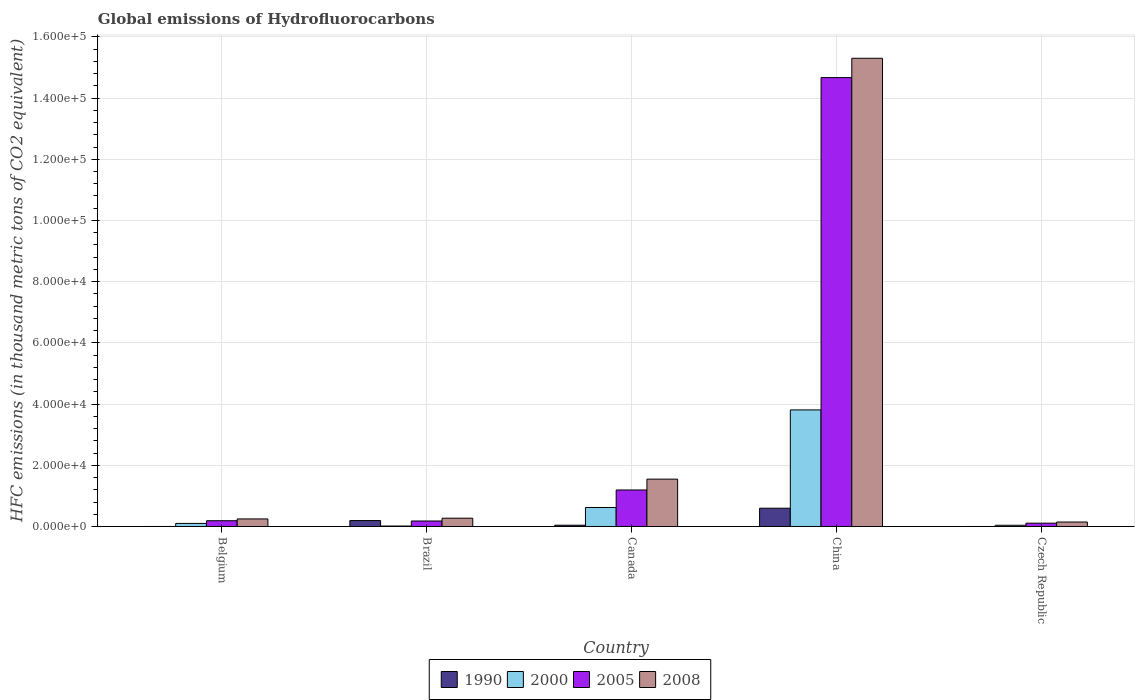How many different coloured bars are there?
Provide a succinct answer. 4. Are the number of bars on each tick of the X-axis equal?
Offer a very short reply. Yes. How many bars are there on the 3rd tick from the right?
Provide a short and direct response. 4. What is the label of the 1st group of bars from the left?
Ensure brevity in your answer.  Belgium. In how many cases, is the number of bars for a given country not equal to the number of legend labels?
Offer a terse response. 0. What is the global emissions of Hydrofluorocarbons in 2000 in Canada?
Your answer should be compact. 6202.8. Across all countries, what is the maximum global emissions of Hydrofluorocarbons in 2008?
Provide a short and direct response. 1.53e+05. Across all countries, what is the minimum global emissions of Hydrofluorocarbons in 2008?
Ensure brevity in your answer.  1459. In which country was the global emissions of Hydrofluorocarbons in 1990 minimum?
Keep it short and to the point. Czech Republic. What is the total global emissions of Hydrofluorocarbons in 2008 in the graph?
Your response must be concise. 1.75e+05. What is the difference between the global emissions of Hydrofluorocarbons in 2005 in Canada and that in China?
Your answer should be compact. -1.35e+05. What is the difference between the global emissions of Hydrofluorocarbons in 2000 in China and the global emissions of Hydrofluorocarbons in 2008 in Canada?
Offer a terse response. 2.26e+04. What is the average global emissions of Hydrofluorocarbons in 2005 per country?
Offer a terse response. 3.27e+04. What is the difference between the global emissions of Hydrofluorocarbons of/in 2008 and global emissions of Hydrofluorocarbons of/in 2005 in China?
Offer a very short reply. 6309. In how many countries, is the global emissions of Hydrofluorocarbons in 2005 greater than 156000 thousand metric tons?
Your answer should be very brief. 0. What is the ratio of the global emissions of Hydrofluorocarbons in 2008 in Belgium to that in China?
Ensure brevity in your answer.  0.02. Is the global emissions of Hydrofluorocarbons in 2008 in Belgium less than that in Canada?
Provide a succinct answer. Yes. Is the difference between the global emissions of Hydrofluorocarbons in 2008 in Brazil and China greater than the difference between the global emissions of Hydrofluorocarbons in 2005 in Brazil and China?
Provide a short and direct response. No. What is the difference between the highest and the second highest global emissions of Hydrofluorocarbons in 2005?
Your answer should be very brief. -1.35e+05. What is the difference between the highest and the lowest global emissions of Hydrofluorocarbons in 2005?
Provide a succinct answer. 1.46e+05. Is it the case that in every country, the sum of the global emissions of Hydrofluorocarbons in 1990 and global emissions of Hydrofluorocarbons in 2008 is greater than the global emissions of Hydrofluorocarbons in 2000?
Ensure brevity in your answer.  Yes. Are all the bars in the graph horizontal?
Provide a succinct answer. No. Are the values on the major ticks of Y-axis written in scientific E-notation?
Provide a short and direct response. Yes. Does the graph contain grids?
Your answer should be compact. Yes. Where does the legend appear in the graph?
Offer a terse response. Bottom center. How are the legend labels stacked?
Ensure brevity in your answer.  Horizontal. What is the title of the graph?
Your response must be concise. Global emissions of Hydrofluorocarbons. Does "2003" appear as one of the legend labels in the graph?
Provide a short and direct response. No. What is the label or title of the X-axis?
Give a very brief answer. Country. What is the label or title of the Y-axis?
Your answer should be very brief. HFC emissions (in thousand metric tons of CO2 equivalent). What is the HFC emissions (in thousand metric tons of CO2 equivalent) in 2000 in Belgium?
Give a very brief answer. 997.7. What is the HFC emissions (in thousand metric tons of CO2 equivalent) in 2005 in Belgium?
Make the answer very short. 1882.6. What is the HFC emissions (in thousand metric tons of CO2 equivalent) in 2008 in Belgium?
Offer a very short reply. 2471.1. What is the HFC emissions (in thousand metric tons of CO2 equivalent) of 1990 in Brazil?
Provide a succinct answer. 1930.7. What is the HFC emissions (in thousand metric tons of CO2 equivalent) of 2000 in Brazil?
Provide a short and direct response. 147.4. What is the HFC emissions (in thousand metric tons of CO2 equivalent) of 2005 in Brazil?
Keep it short and to the point. 1793.4. What is the HFC emissions (in thousand metric tons of CO2 equivalent) in 2008 in Brazil?
Provide a short and direct response. 2707.5. What is the HFC emissions (in thousand metric tons of CO2 equivalent) of 1990 in Canada?
Offer a terse response. 418.5. What is the HFC emissions (in thousand metric tons of CO2 equivalent) of 2000 in Canada?
Your answer should be compact. 6202.8. What is the HFC emissions (in thousand metric tons of CO2 equivalent) of 2005 in Canada?
Your answer should be very brief. 1.19e+04. What is the HFC emissions (in thousand metric tons of CO2 equivalent) of 2008 in Canada?
Keep it short and to the point. 1.55e+04. What is the HFC emissions (in thousand metric tons of CO2 equivalent) of 1990 in China?
Your response must be concise. 5970.1. What is the HFC emissions (in thousand metric tons of CO2 equivalent) of 2000 in China?
Offer a very short reply. 3.81e+04. What is the HFC emissions (in thousand metric tons of CO2 equivalent) in 2005 in China?
Provide a succinct answer. 1.47e+05. What is the HFC emissions (in thousand metric tons of CO2 equivalent) in 2008 in China?
Provide a short and direct response. 1.53e+05. What is the HFC emissions (in thousand metric tons of CO2 equivalent) of 1990 in Czech Republic?
Make the answer very short. 0.1. What is the HFC emissions (in thousand metric tons of CO2 equivalent) in 2000 in Czech Republic?
Your response must be concise. 399.5. What is the HFC emissions (in thousand metric tons of CO2 equivalent) of 2005 in Czech Republic?
Provide a short and direct response. 1078.7. What is the HFC emissions (in thousand metric tons of CO2 equivalent) in 2008 in Czech Republic?
Make the answer very short. 1459. Across all countries, what is the maximum HFC emissions (in thousand metric tons of CO2 equivalent) in 1990?
Make the answer very short. 5970.1. Across all countries, what is the maximum HFC emissions (in thousand metric tons of CO2 equivalent) of 2000?
Your response must be concise. 3.81e+04. Across all countries, what is the maximum HFC emissions (in thousand metric tons of CO2 equivalent) of 2005?
Your answer should be very brief. 1.47e+05. Across all countries, what is the maximum HFC emissions (in thousand metric tons of CO2 equivalent) of 2008?
Give a very brief answer. 1.53e+05. Across all countries, what is the minimum HFC emissions (in thousand metric tons of CO2 equivalent) in 1990?
Offer a very short reply. 0.1. Across all countries, what is the minimum HFC emissions (in thousand metric tons of CO2 equivalent) in 2000?
Your answer should be very brief. 147.4. Across all countries, what is the minimum HFC emissions (in thousand metric tons of CO2 equivalent) of 2005?
Make the answer very short. 1078.7. Across all countries, what is the minimum HFC emissions (in thousand metric tons of CO2 equivalent) in 2008?
Offer a very short reply. 1459. What is the total HFC emissions (in thousand metric tons of CO2 equivalent) of 1990 in the graph?
Offer a very short reply. 8319.9. What is the total HFC emissions (in thousand metric tons of CO2 equivalent) in 2000 in the graph?
Your answer should be compact. 4.58e+04. What is the total HFC emissions (in thousand metric tons of CO2 equivalent) in 2005 in the graph?
Provide a short and direct response. 1.63e+05. What is the total HFC emissions (in thousand metric tons of CO2 equivalent) in 2008 in the graph?
Your response must be concise. 1.75e+05. What is the difference between the HFC emissions (in thousand metric tons of CO2 equivalent) in 1990 in Belgium and that in Brazil?
Keep it short and to the point. -1930.2. What is the difference between the HFC emissions (in thousand metric tons of CO2 equivalent) of 2000 in Belgium and that in Brazil?
Provide a succinct answer. 850.3. What is the difference between the HFC emissions (in thousand metric tons of CO2 equivalent) of 2005 in Belgium and that in Brazil?
Give a very brief answer. 89.2. What is the difference between the HFC emissions (in thousand metric tons of CO2 equivalent) in 2008 in Belgium and that in Brazil?
Your response must be concise. -236.4. What is the difference between the HFC emissions (in thousand metric tons of CO2 equivalent) in 1990 in Belgium and that in Canada?
Your answer should be compact. -418. What is the difference between the HFC emissions (in thousand metric tons of CO2 equivalent) in 2000 in Belgium and that in Canada?
Your response must be concise. -5205.1. What is the difference between the HFC emissions (in thousand metric tons of CO2 equivalent) in 2005 in Belgium and that in Canada?
Keep it short and to the point. -1.00e+04. What is the difference between the HFC emissions (in thousand metric tons of CO2 equivalent) of 2008 in Belgium and that in Canada?
Give a very brief answer. -1.30e+04. What is the difference between the HFC emissions (in thousand metric tons of CO2 equivalent) in 1990 in Belgium and that in China?
Provide a succinct answer. -5969.6. What is the difference between the HFC emissions (in thousand metric tons of CO2 equivalent) of 2000 in Belgium and that in China?
Keep it short and to the point. -3.71e+04. What is the difference between the HFC emissions (in thousand metric tons of CO2 equivalent) in 2005 in Belgium and that in China?
Your answer should be very brief. -1.45e+05. What is the difference between the HFC emissions (in thousand metric tons of CO2 equivalent) in 2008 in Belgium and that in China?
Your answer should be compact. -1.51e+05. What is the difference between the HFC emissions (in thousand metric tons of CO2 equivalent) in 1990 in Belgium and that in Czech Republic?
Give a very brief answer. 0.4. What is the difference between the HFC emissions (in thousand metric tons of CO2 equivalent) of 2000 in Belgium and that in Czech Republic?
Offer a terse response. 598.2. What is the difference between the HFC emissions (in thousand metric tons of CO2 equivalent) in 2005 in Belgium and that in Czech Republic?
Give a very brief answer. 803.9. What is the difference between the HFC emissions (in thousand metric tons of CO2 equivalent) of 2008 in Belgium and that in Czech Republic?
Your response must be concise. 1012.1. What is the difference between the HFC emissions (in thousand metric tons of CO2 equivalent) of 1990 in Brazil and that in Canada?
Ensure brevity in your answer.  1512.2. What is the difference between the HFC emissions (in thousand metric tons of CO2 equivalent) in 2000 in Brazil and that in Canada?
Offer a terse response. -6055.4. What is the difference between the HFC emissions (in thousand metric tons of CO2 equivalent) of 2005 in Brazil and that in Canada?
Provide a short and direct response. -1.01e+04. What is the difference between the HFC emissions (in thousand metric tons of CO2 equivalent) of 2008 in Brazil and that in Canada?
Your answer should be very brief. -1.28e+04. What is the difference between the HFC emissions (in thousand metric tons of CO2 equivalent) in 1990 in Brazil and that in China?
Your answer should be compact. -4039.4. What is the difference between the HFC emissions (in thousand metric tons of CO2 equivalent) in 2000 in Brazil and that in China?
Your answer should be very brief. -3.79e+04. What is the difference between the HFC emissions (in thousand metric tons of CO2 equivalent) in 2005 in Brazil and that in China?
Ensure brevity in your answer.  -1.45e+05. What is the difference between the HFC emissions (in thousand metric tons of CO2 equivalent) in 2008 in Brazil and that in China?
Make the answer very short. -1.50e+05. What is the difference between the HFC emissions (in thousand metric tons of CO2 equivalent) in 1990 in Brazil and that in Czech Republic?
Keep it short and to the point. 1930.6. What is the difference between the HFC emissions (in thousand metric tons of CO2 equivalent) in 2000 in Brazil and that in Czech Republic?
Give a very brief answer. -252.1. What is the difference between the HFC emissions (in thousand metric tons of CO2 equivalent) in 2005 in Brazil and that in Czech Republic?
Keep it short and to the point. 714.7. What is the difference between the HFC emissions (in thousand metric tons of CO2 equivalent) of 2008 in Brazil and that in Czech Republic?
Provide a short and direct response. 1248.5. What is the difference between the HFC emissions (in thousand metric tons of CO2 equivalent) of 1990 in Canada and that in China?
Provide a short and direct response. -5551.6. What is the difference between the HFC emissions (in thousand metric tons of CO2 equivalent) of 2000 in Canada and that in China?
Your response must be concise. -3.19e+04. What is the difference between the HFC emissions (in thousand metric tons of CO2 equivalent) in 2005 in Canada and that in China?
Keep it short and to the point. -1.35e+05. What is the difference between the HFC emissions (in thousand metric tons of CO2 equivalent) in 2008 in Canada and that in China?
Offer a terse response. -1.38e+05. What is the difference between the HFC emissions (in thousand metric tons of CO2 equivalent) of 1990 in Canada and that in Czech Republic?
Your answer should be very brief. 418.4. What is the difference between the HFC emissions (in thousand metric tons of CO2 equivalent) in 2000 in Canada and that in Czech Republic?
Give a very brief answer. 5803.3. What is the difference between the HFC emissions (in thousand metric tons of CO2 equivalent) in 2005 in Canada and that in Czech Republic?
Make the answer very short. 1.08e+04. What is the difference between the HFC emissions (in thousand metric tons of CO2 equivalent) of 2008 in Canada and that in Czech Republic?
Provide a short and direct response. 1.40e+04. What is the difference between the HFC emissions (in thousand metric tons of CO2 equivalent) in 1990 in China and that in Czech Republic?
Keep it short and to the point. 5970. What is the difference between the HFC emissions (in thousand metric tons of CO2 equivalent) of 2000 in China and that in Czech Republic?
Keep it short and to the point. 3.77e+04. What is the difference between the HFC emissions (in thousand metric tons of CO2 equivalent) of 2005 in China and that in Czech Republic?
Offer a very short reply. 1.46e+05. What is the difference between the HFC emissions (in thousand metric tons of CO2 equivalent) in 2008 in China and that in Czech Republic?
Your response must be concise. 1.52e+05. What is the difference between the HFC emissions (in thousand metric tons of CO2 equivalent) of 1990 in Belgium and the HFC emissions (in thousand metric tons of CO2 equivalent) of 2000 in Brazil?
Offer a very short reply. -146.9. What is the difference between the HFC emissions (in thousand metric tons of CO2 equivalent) in 1990 in Belgium and the HFC emissions (in thousand metric tons of CO2 equivalent) in 2005 in Brazil?
Make the answer very short. -1792.9. What is the difference between the HFC emissions (in thousand metric tons of CO2 equivalent) in 1990 in Belgium and the HFC emissions (in thousand metric tons of CO2 equivalent) in 2008 in Brazil?
Offer a very short reply. -2707. What is the difference between the HFC emissions (in thousand metric tons of CO2 equivalent) in 2000 in Belgium and the HFC emissions (in thousand metric tons of CO2 equivalent) in 2005 in Brazil?
Keep it short and to the point. -795.7. What is the difference between the HFC emissions (in thousand metric tons of CO2 equivalent) in 2000 in Belgium and the HFC emissions (in thousand metric tons of CO2 equivalent) in 2008 in Brazil?
Offer a terse response. -1709.8. What is the difference between the HFC emissions (in thousand metric tons of CO2 equivalent) in 2005 in Belgium and the HFC emissions (in thousand metric tons of CO2 equivalent) in 2008 in Brazil?
Keep it short and to the point. -824.9. What is the difference between the HFC emissions (in thousand metric tons of CO2 equivalent) in 1990 in Belgium and the HFC emissions (in thousand metric tons of CO2 equivalent) in 2000 in Canada?
Your answer should be compact. -6202.3. What is the difference between the HFC emissions (in thousand metric tons of CO2 equivalent) of 1990 in Belgium and the HFC emissions (in thousand metric tons of CO2 equivalent) of 2005 in Canada?
Offer a very short reply. -1.19e+04. What is the difference between the HFC emissions (in thousand metric tons of CO2 equivalent) of 1990 in Belgium and the HFC emissions (in thousand metric tons of CO2 equivalent) of 2008 in Canada?
Offer a terse response. -1.55e+04. What is the difference between the HFC emissions (in thousand metric tons of CO2 equivalent) in 2000 in Belgium and the HFC emissions (in thousand metric tons of CO2 equivalent) in 2005 in Canada?
Keep it short and to the point. -1.09e+04. What is the difference between the HFC emissions (in thousand metric tons of CO2 equivalent) of 2000 in Belgium and the HFC emissions (in thousand metric tons of CO2 equivalent) of 2008 in Canada?
Offer a very short reply. -1.45e+04. What is the difference between the HFC emissions (in thousand metric tons of CO2 equivalent) of 2005 in Belgium and the HFC emissions (in thousand metric tons of CO2 equivalent) of 2008 in Canada?
Your answer should be very brief. -1.36e+04. What is the difference between the HFC emissions (in thousand metric tons of CO2 equivalent) of 1990 in Belgium and the HFC emissions (in thousand metric tons of CO2 equivalent) of 2000 in China?
Offer a very short reply. -3.81e+04. What is the difference between the HFC emissions (in thousand metric tons of CO2 equivalent) of 1990 in Belgium and the HFC emissions (in thousand metric tons of CO2 equivalent) of 2005 in China?
Offer a very short reply. -1.47e+05. What is the difference between the HFC emissions (in thousand metric tons of CO2 equivalent) of 1990 in Belgium and the HFC emissions (in thousand metric tons of CO2 equivalent) of 2008 in China?
Offer a terse response. -1.53e+05. What is the difference between the HFC emissions (in thousand metric tons of CO2 equivalent) of 2000 in Belgium and the HFC emissions (in thousand metric tons of CO2 equivalent) of 2005 in China?
Your answer should be very brief. -1.46e+05. What is the difference between the HFC emissions (in thousand metric tons of CO2 equivalent) in 2000 in Belgium and the HFC emissions (in thousand metric tons of CO2 equivalent) in 2008 in China?
Provide a succinct answer. -1.52e+05. What is the difference between the HFC emissions (in thousand metric tons of CO2 equivalent) in 2005 in Belgium and the HFC emissions (in thousand metric tons of CO2 equivalent) in 2008 in China?
Offer a very short reply. -1.51e+05. What is the difference between the HFC emissions (in thousand metric tons of CO2 equivalent) of 1990 in Belgium and the HFC emissions (in thousand metric tons of CO2 equivalent) of 2000 in Czech Republic?
Your answer should be compact. -399. What is the difference between the HFC emissions (in thousand metric tons of CO2 equivalent) of 1990 in Belgium and the HFC emissions (in thousand metric tons of CO2 equivalent) of 2005 in Czech Republic?
Your response must be concise. -1078.2. What is the difference between the HFC emissions (in thousand metric tons of CO2 equivalent) in 1990 in Belgium and the HFC emissions (in thousand metric tons of CO2 equivalent) in 2008 in Czech Republic?
Your response must be concise. -1458.5. What is the difference between the HFC emissions (in thousand metric tons of CO2 equivalent) of 2000 in Belgium and the HFC emissions (in thousand metric tons of CO2 equivalent) of 2005 in Czech Republic?
Provide a short and direct response. -81. What is the difference between the HFC emissions (in thousand metric tons of CO2 equivalent) of 2000 in Belgium and the HFC emissions (in thousand metric tons of CO2 equivalent) of 2008 in Czech Republic?
Keep it short and to the point. -461.3. What is the difference between the HFC emissions (in thousand metric tons of CO2 equivalent) in 2005 in Belgium and the HFC emissions (in thousand metric tons of CO2 equivalent) in 2008 in Czech Republic?
Ensure brevity in your answer.  423.6. What is the difference between the HFC emissions (in thousand metric tons of CO2 equivalent) in 1990 in Brazil and the HFC emissions (in thousand metric tons of CO2 equivalent) in 2000 in Canada?
Keep it short and to the point. -4272.1. What is the difference between the HFC emissions (in thousand metric tons of CO2 equivalent) in 1990 in Brazil and the HFC emissions (in thousand metric tons of CO2 equivalent) in 2005 in Canada?
Keep it short and to the point. -9997.7. What is the difference between the HFC emissions (in thousand metric tons of CO2 equivalent) of 1990 in Brazil and the HFC emissions (in thousand metric tons of CO2 equivalent) of 2008 in Canada?
Ensure brevity in your answer.  -1.35e+04. What is the difference between the HFC emissions (in thousand metric tons of CO2 equivalent) of 2000 in Brazil and the HFC emissions (in thousand metric tons of CO2 equivalent) of 2005 in Canada?
Provide a short and direct response. -1.18e+04. What is the difference between the HFC emissions (in thousand metric tons of CO2 equivalent) of 2000 in Brazil and the HFC emissions (in thousand metric tons of CO2 equivalent) of 2008 in Canada?
Keep it short and to the point. -1.53e+04. What is the difference between the HFC emissions (in thousand metric tons of CO2 equivalent) of 2005 in Brazil and the HFC emissions (in thousand metric tons of CO2 equivalent) of 2008 in Canada?
Offer a terse response. -1.37e+04. What is the difference between the HFC emissions (in thousand metric tons of CO2 equivalent) in 1990 in Brazil and the HFC emissions (in thousand metric tons of CO2 equivalent) in 2000 in China?
Provide a short and direct response. -3.62e+04. What is the difference between the HFC emissions (in thousand metric tons of CO2 equivalent) of 1990 in Brazil and the HFC emissions (in thousand metric tons of CO2 equivalent) of 2005 in China?
Your answer should be very brief. -1.45e+05. What is the difference between the HFC emissions (in thousand metric tons of CO2 equivalent) in 1990 in Brazil and the HFC emissions (in thousand metric tons of CO2 equivalent) in 2008 in China?
Keep it short and to the point. -1.51e+05. What is the difference between the HFC emissions (in thousand metric tons of CO2 equivalent) of 2000 in Brazil and the HFC emissions (in thousand metric tons of CO2 equivalent) of 2005 in China?
Make the answer very short. -1.47e+05. What is the difference between the HFC emissions (in thousand metric tons of CO2 equivalent) in 2000 in Brazil and the HFC emissions (in thousand metric tons of CO2 equivalent) in 2008 in China?
Your answer should be very brief. -1.53e+05. What is the difference between the HFC emissions (in thousand metric tons of CO2 equivalent) of 2005 in Brazil and the HFC emissions (in thousand metric tons of CO2 equivalent) of 2008 in China?
Your answer should be very brief. -1.51e+05. What is the difference between the HFC emissions (in thousand metric tons of CO2 equivalent) in 1990 in Brazil and the HFC emissions (in thousand metric tons of CO2 equivalent) in 2000 in Czech Republic?
Ensure brevity in your answer.  1531.2. What is the difference between the HFC emissions (in thousand metric tons of CO2 equivalent) of 1990 in Brazil and the HFC emissions (in thousand metric tons of CO2 equivalent) of 2005 in Czech Republic?
Offer a terse response. 852. What is the difference between the HFC emissions (in thousand metric tons of CO2 equivalent) in 1990 in Brazil and the HFC emissions (in thousand metric tons of CO2 equivalent) in 2008 in Czech Republic?
Your answer should be very brief. 471.7. What is the difference between the HFC emissions (in thousand metric tons of CO2 equivalent) in 2000 in Brazil and the HFC emissions (in thousand metric tons of CO2 equivalent) in 2005 in Czech Republic?
Provide a short and direct response. -931.3. What is the difference between the HFC emissions (in thousand metric tons of CO2 equivalent) in 2000 in Brazil and the HFC emissions (in thousand metric tons of CO2 equivalent) in 2008 in Czech Republic?
Keep it short and to the point. -1311.6. What is the difference between the HFC emissions (in thousand metric tons of CO2 equivalent) in 2005 in Brazil and the HFC emissions (in thousand metric tons of CO2 equivalent) in 2008 in Czech Republic?
Keep it short and to the point. 334.4. What is the difference between the HFC emissions (in thousand metric tons of CO2 equivalent) in 1990 in Canada and the HFC emissions (in thousand metric tons of CO2 equivalent) in 2000 in China?
Offer a very short reply. -3.77e+04. What is the difference between the HFC emissions (in thousand metric tons of CO2 equivalent) of 1990 in Canada and the HFC emissions (in thousand metric tons of CO2 equivalent) of 2005 in China?
Make the answer very short. -1.46e+05. What is the difference between the HFC emissions (in thousand metric tons of CO2 equivalent) in 1990 in Canada and the HFC emissions (in thousand metric tons of CO2 equivalent) in 2008 in China?
Give a very brief answer. -1.53e+05. What is the difference between the HFC emissions (in thousand metric tons of CO2 equivalent) of 2000 in Canada and the HFC emissions (in thousand metric tons of CO2 equivalent) of 2005 in China?
Offer a terse response. -1.40e+05. What is the difference between the HFC emissions (in thousand metric tons of CO2 equivalent) of 2000 in Canada and the HFC emissions (in thousand metric tons of CO2 equivalent) of 2008 in China?
Ensure brevity in your answer.  -1.47e+05. What is the difference between the HFC emissions (in thousand metric tons of CO2 equivalent) in 2005 in Canada and the HFC emissions (in thousand metric tons of CO2 equivalent) in 2008 in China?
Your answer should be compact. -1.41e+05. What is the difference between the HFC emissions (in thousand metric tons of CO2 equivalent) of 1990 in Canada and the HFC emissions (in thousand metric tons of CO2 equivalent) of 2000 in Czech Republic?
Give a very brief answer. 19. What is the difference between the HFC emissions (in thousand metric tons of CO2 equivalent) in 1990 in Canada and the HFC emissions (in thousand metric tons of CO2 equivalent) in 2005 in Czech Republic?
Provide a short and direct response. -660.2. What is the difference between the HFC emissions (in thousand metric tons of CO2 equivalent) of 1990 in Canada and the HFC emissions (in thousand metric tons of CO2 equivalent) of 2008 in Czech Republic?
Give a very brief answer. -1040.5. What is the difference between the HFC emissions (in thousand metric tons of CO2 equivalent) of 2000 in Canada and the HFC emissions (in thousand metric tons of CO2 equivalent) of 2005 in Czech Republic?
Make the answer very short. 5124.1. What is the difference between the HFC emissions (in thousand metric tons of CO2 equivalent) of 2000 in Canada and the HFC emissions (in thousand metric tons of CO2 equivalent) of 2008 in Czech Republic?
Offer a terse response. 4743.8. What is the difference between the HFC emissions (in thousand metric tons of CO2 equivalent) in 2005 in Canada and the HFC emissions (in thousand metric tons of CO2 equivalent) in 2008 in Czech Republic?
Make the answer very short. 1.05e+04. What is the difference between the HFC emissions (in thousand metric tons of CO2 equivalent) of 1990 in China and the HFC emissions (in thousand metric tons of CO2 equivalent) of 2000 in Czech Republic?
Ensure brevity in your answer.  5570.6. What is the difference between the HFC emissions (in thousand metric tons of CO2 equivalent) in 1990 in China and the HFC emissions (in thousand metric tons of CO2 equivalent) in 2005 in Czech Republic?
Offer a very short reply. 4891.4. What is the difference between the HFC emissions (in thousand metric tons of CO2 equivalent) of 1990 in China and the HFC emissions (in thousand metric tons of CO2 equivalent) of 2008 in Czech Republic?
Make the answer very short. 4511.1. What is the difference between the HFC emissions (in thousand metric tons of CO2 equivalent) of 2000 in China and the HFC emissions (in thousand metric tons of CO2 equivalent) of 2005 in Czech Republic?
Offer a terse response. 3.70e+04. What is the difference between the HFC emissions (in thousand metric tons of CO2 equivalent) in 2000 in China and the HFC emissions (in thousand metric tons of CO2 equivalent) in 2008 in Czech Republic?
Offer a terse response. 3.66e+04. What is the difference between the HFC emissions (in thousand metric tons of CO2 equivalent) in 2005 in China and the HFC emissions (in thousand metric tons of CO2 equivalent) in 2008 in Czech Republic?
Offer a terse response. 1.45e+05. What is the average HFC emissions (in thousand metric tons of CO2 equivalent) of 1990 per country?
Provide a succinct answer. 1663.98. What is the average HFC emissions (in thousand metric tons of CO2 equivalent) in 2000 per country?
Provide a short and direct response. 9168.28. What is the average HFC emissions (in thousand metric tons of CO2 equivalent) of 2005 per country?
Keep it short and to the point. 3.27e+04. What is the average HFC emissions (in thousand metric tons of CO2 equivalent) of 2008 per country?
Make the answer very short. 3.50e+04. What is the difference between the HFC emissions (in thousand metric tons of CO2 equivalent) in 1990 and HFC emissions (in thousand metric tons of CO2 equivalent) in 2000 in Belgium?
Give a very brief answer. -997.2. What is the difference between the HFC emissions (in thousand metric tons of CO2 equivalent) of 1990 and HFC emissions (in thousand metric tons of CO2 equivalent) of 2005 in Belgium?
Offer a terse response. -1882.1. What is the difference between the HFC emissions (in thousand metric tons of CO2 equivalent) of 1990 and HFC emissions (in thousand metric tons of CO2 equivalent) of 2008 in Belgium?
Give a very brief answer. -2470.6. What is the difference between the HFC emissions (in thousand metric tons of CO2 equivalent) in 2000 and HFC emissions (in thousand metric tons of CO2 equivalent) in 2005 in Belgium?
Give a very brief answer. -884.9. What is the difference between the HFC emissions (in thousand metric tons of CO2 equivalent) of 2000 and HFC emissions (in thousand metric tons of CO2 equivalent) of 2008 in Belgium?
Make the answer very short. -1473.4. What is the difference between the HFC emissions (in thousand metric tons of CO2 equivalent) in 2005 and HFC emissions (in thousand metric tons of CO2 equivalent) in 2008 in Belgium?
Give a very brief answer. -588.5. What is the difference between the HFC emissions (in thousand metric tons of CO2 equivalent) of 1990 and HFC emissions (in thousand metric tons of CO2 equivalent) of 2000 in Brazil?
Ensure brevity in your answer.  1783.3. What is the difference between the HFC emissions (in thousand metric tons of CO2 equivalent) in 1990 and HFC emissions (in thousand metric tons of CO2 equivalent) in 2005 in Brazil?
Make the answer very short. 137.3. What is the difference between the HFC emissions (in thousand metric tons of CO2 equivalent) in 1990 and HFC emissions (in thousand metric tons of CO2 equivalent) in 2008 in Brazil?
Provide a short and direct response. -776.8. What is the difference between the HFC emissions (in thousand metric tons of CO2 equivalent) in 2000 and HFC emissions (in thousand metric tons of CO2 equivalent) in 2005 in Brazil?
Ensure brevity in your answer.  -1646. What is the difference between the HFC emissions (in thousand metric tons of CO2 equivalent) in 2000 and HFC emissions (in thousand metric tons of CO2 equivalent) in 2008 in Brazil?
Keep it short and to the point. -2560.1. What is the difference between the HFC emissions (in thousand metric tons of CO2 equivalent) of 2005 and HFC emissions (in thousand metric tons of CO2 equivalent) of 2008 in Brazil?
Your response must be concise. -914.1. What is the difference between the HFC emissions (in thousand metric tons of CO2 equivalent) of 1990 and HFC emissions (in thousand metric tons of CO2 equivalent) of 2000 in Canada?
Your answer should be very brief. -5784.3. What is the difference between the HFC emissions (in thousand metric tons of CO2 equivalent) in 1990 and HFC emissions (in thousand metric tons of CO2 equivalent) in 2005 in Canada?
Make the answer very short. -1.15e+04. What is the difference between the HFC emissions (in thousand metric tons of CO2 equivalent) of 1990 and HFC emissions (in thousand metric tons of CO2 equivalent) of 2008 in Canada?
Keep it short and to the point. -1.51e+04. What is the difference between the HFC emissions (in thousand metric tons of CO2 equivalent) of 2000 and HFC emissions (in thousand metric tons of CO2 equivalent) of 2005 in Canada?
Ensure brevity in your answer.  -5725.6. What is the difference between the HFC emissions (in thousand metric tons of CO2 equivalent) of 2000 and HFC emissions (in thousand metric tons of CO2 equivalent) of 2008 in Canada?
Your response must be concise. -9272. What is the difference between the HFC emissions (in thousand metric tons of CO2 equivalent) in 2005 and HFC emissions (in thousand metric tons of CO2 equivalent) in 2008 in Canada?
Your response must be concise. -3546.4. What is the difference between the HFC emissions (in thousand metric tons of CO2 equivalent) in 1990 and HFC emissions (in thousand metric tons of CO2 equivalent) in 2000 in China?
Your answer should be compact. -3.21e+04. What is the difference between the HFC emissions (in thousand metric tons of CO2 equivalent) in 1990 and HFC emissions (in thousand metric tons of CO2 equivalent) in 2005 in China?
Make the answer very short. -1.41e+05. What is the difference between the HFC emissions (in thousand metric tons of CO2 equivalent) of 1990 and HFC emissions (in thousand metric tons of CO2 equivalent) of 2008 in China?
Your response must be concise. -1.47e+05. What is the difference between the HFC emissions (in thousand metric tons of CO2 equivalent) in 2000 and HFC emissions (in thousand metric tons of CO2 equivalent) in 2005 in China?
Your answer should be very brief. -1.09e+05. What is the difference between the HFC emissions (in thousand metric tons of CO2 equivalent) in 2000 and HFC emissions (in thousand metric tons of CO2 equivalent) in 2008 in China?
Provide a succinct answer. -1.15e+05. What is the difference between the HFC emissions (in thousand metric tons of CO2 equivalent) of 2005 and HFC emissions (in thousand metric tons of CO2 equivalent) of 2008 in China?
Offer a very short reply. -6309. What is the difference between the HFC emissions (in thousand metric tons of CO2 equivalent) in 1990 and HFC emissions (in thousand metric tons of CO2 equivalent) in 2000 in Czech Republic?
Your answer should be compact. -399.4. What is the difference between the HFC emissions (in thousand metric tons of CO2 equivalent) in 1990 and HFC emissions (in thousand metric tons of CO2 equivalent) in 2005 in Czech Republic?
Keep it short and to the point. -1078.6. What is the difference between the HFC emissions (in thousand metric tons of CO2 equivalent) of 1990 and HFC emissions (in thousand metric tons of CO2 equivalent) of 2008 in Czech Republic?
Provide a short and direct response. -1458.9. What is the difference between the HFC emissions (in thousand metric tons of CO2 equivalent) of 2000 and HFC emissions (in thousand metric tons of CO2 equivalent) of 2005 in Czech Republic?
Make the answer very short. -679.2. What is the difference between the HFC emissions (in thousand metric tons of CO2 equivalent) of 2000 and HFC emissions (in thousand metric tons of CO2 equivalent) of 2008 in Czech Republic?
Offer a very short reply. -1059.5. What is the difference between the HFC emissions (in thousand metric tons of CO2 equivalent) of 2005 and HFC emissions (in thousand metric tons of CO2 equivalent) of 2008 in Czech Republic?
Your answer should be very brief. -380.3. What is the ratio of the HFC emissions (in thousand metric tons of CO2 equivalent) in 1990 in Belgium to that in Brazil?
Your answer should be compact. 0. What is the ratio of the HFC emissions (in thousand metric tons of CO2 equivalent) in 2000 in Belgium to that in Brazil?
Give a very brief answer. 6.77. What is the ratio of the HFC emissions (in thousand metric tons of CO2 equivalent) in 2005 in Belgium to that in Brazil?
Provide a succinct answer. 1.05. What is the ratio of the HFC emissions (in thousand metric tons of CO2 equivalent) in 2008 in Belgium to that in Brazil?
Keep it short and to the point. 0.91. What is the ratio of the HFC emissions (in thousand metric tons of CO2 equivalent) in 1990 in Belgium to that in Canada?
Provide a short and direct response. 0. What is the ratio of the HFC emissions (in thousand metric tons of CO2 equivalent) in 2000 in Belgium to that in Canada?
Offer a terse response. 0.16. What is the ratio of the HFC emissions (in thousand metric tons of CO2 equivalent) in 2005 in Belgium to that in Canada?
Your answer should be very brief. 0.16. What is the ratio of the HFC emissions (in thousand metric tons of CO2 equivalent) of 2008 in Belgium to that in Canada?
Your answer should be very brief. 0.16. What is the ratio of the HFC emissions (in thousand metric tons of CO2 equivalent) in 2000 in Belgium to that in China?
Give a very brief answer. 0.03. What is the ratio of the HFC emissions (in thousand metric tons of CO2 equivalent) in 2005 in Belgium to that in China?
Your answer should be very brief. 0.01. What is the ratio of the HFC emissions (in thousand metric tons of CO2 equivalent) in 2008 in Belgium to that in China?
Your response must be concise. 0.02. What is the ratio of the HFC emissions (in thousand metric tons of CO2 equivalent) in 2000 in Belgium to that in Czech Republic?
Provide a succinct answer. 2.5. What is the ratio of the HFC emissions (in thousand metric tons of CO2 equivalent) of 2005 in Belgium to that in Czech Republic?
Your answer should be compact. 1.75. What is the ratio of the HFC emissions (in thousand metric tons of CO2 equivalent) of 2008 in Belgium to that in Czech Republic?
Keep it short and to the point. 1.69. What is the ratio of the HFC emissions (in thousand metric tons of CO2 equivalent) of 1990 in Brazil to that in Canada?
Your response must be concise. 4.61. What is the ratio of the HFC emissions (in thousand metric tons of CO2 equivalent) of 2000 in Brazil to that in Canada?
Offer a terse response. 0.02. What is the ratio of the HFC emissions (in thousand metric tons of CO2 equivalent) in 2005 in Brazil to that in Canada?
Provide a short and direct response. 0.15. What is the ratio of the HFC emissions (in thousand metric tons of CO2 equivalent) in 2008 in Brazil to that in Canada?
Provide a succinct answer. 0.17. What is the ratio of the HFC emissions (in thousand metric tons of CO2 equivalent) of 1990 in Brazil to that in China?
Offer a terse response. 0.32. What is the ratio of the HFC emissions (in thousand metric tons of CO2 equivalent) of 2000 in Brazil to that in China?
Offer a terse response. 0. What is the ratio of the HFC emissions (in thousand metric tons of CO2 equivalent) of 2005 in Brazil to that in China?
Make the answer very short. 0.01. What is the ratio of the HFC emissions (in thousand metric tons of CO2 equivalent) of 2008 in Brazil to that in China?
Provide a succinct answer. 0.02. What is the ratio of the HFC emissions (in thousand metric tons of CO2 equivalent) in 1990 in Brazil to that in Czech Republic?
Your response must be concise. 1.93e+04. What is the ratio of the HFC emissions (in thousand metric tons of CO2 equivalent) of 2000 in Brazil to that in Czech Republic?
Provide a succinct answer. 0.37. What is the ratio of the HFC emissions (in thousand metric tons of CO2 equivalent) in 2005 in Brazil to that in Czech Republic?
Offer a terse response. 1.66. What is the ratio of the HFC emissions (in thousand metric tons of CO2 equivalent) in 2008 in Brazil to that in Czech Republic?
Provide a succinct answer. 1.86. What is the ratio of the HFC emissions (in thousand metric tons of CO2 equivalent) in 1990 in Canada to that in China?
Offer a terse response. 0.07. What is the ratio of the HFC emissions (in thousand metric tons of CO2 equivalent) in 2000 in Canada to that in China?
Offer a very short reply. 0.16. What is the ratio of the HFC emissions (in thousand metric tons of CO2 equivalent) of 2005 in Canada to that in China?
Offer a terse response. 0.08. What is the ratio of the HFC emissions (in thousand metric tons of CO2 equivalent) of 2008 in Canada to that in China?
Ensure brevity in your answer.  0.1. What is the ratio of the HFC emissions (in thousand metric tons of CO2 equivalent) of 1990 in Canada to that in Czech Republic?
Offer a terse response. 4185. What is the ratio of the HFC emissions (in thousand metric tons of CO2 equivalent) in 2000 in Canada to that in Czech Republic?
Give a very brief answer. 15.53. What is the ratio of the HFC emissions (in thousand metric tons of CO2 equivalent) in 2005 in Canada to that in Czech Republic?
Offer a very short reply. 11.06. What is the ratio of the HFC emissions (in thousand metric tons of CO2 equivalent) in 2008 in Canada to that in Czech Republic?
Your response must be concise. 10.61. What is the ratio of the HFC emissions (in thousand metric tons of CO2 equivalent) of 1990 in China to that in Czech Republic?
Your response must be concise. 5.97e+04. What is the ratio of the HFC emissions (in thousand metric tons of CO2 equivalent) of 2000 in China to that in Czech Republic?
Provide a short and direct response. 95.35. What is the ratio of the HFC emissions (in thousand metric tons of CO2 equivalent) in 2005 in China to that in Czech Republic?
Provide a succinct answer. 135.99. What is the ratio of the HFC emissions (in thousand metric tons of CO2 equivalent) in 2008 in China to that in Czech Republic?
Provide a succinct answer. 104.87. What is the difference between the highest and the second highest HFC emissions (in thousand metric tons of CO2 equivalent) of 1990?
Ensure brevity in your answer.  4039.4. What is the difference between the highest and the second highest HFC emissions (in thousand metric tons of CO2 equivalent) of 2000?
Make the answer very short. 3.19e+04. What is the difference between the highest and the second highest HFC emissions (in thousand metric tons of CO2 equivalent) in 2005?
Provide a short and direct response. 1.35e+05. What is the difference between the highest and the second highest HFC emissions (in thousand metric tons of CO2 equivalent) in 2008?
Ensure brevity in your answer.  1.38e+05. What is the difference between the highest and the lowest HFC emissions (in thousand metric tons of CO2 equivalent) in 1990?
Your response must be concise. 5970. What is the difference between the highest and the lowest HFC emissions (in thousand metric tons of CO2 equivalent) of 2000?
Provide a succinct answer. 3.79e+04. What is the difference between the highest and the lowest HFC emissions (in thousand metric tons of CO2 equivalent) of 2005?
Ensure brevity in your answer.  1.46e+05. What is the difference between the highest and the lowest HFC emissions (in thousand metric tons of CO2 equivalent) in 2008?
Provide a succinct answer. 1.52e+05. 